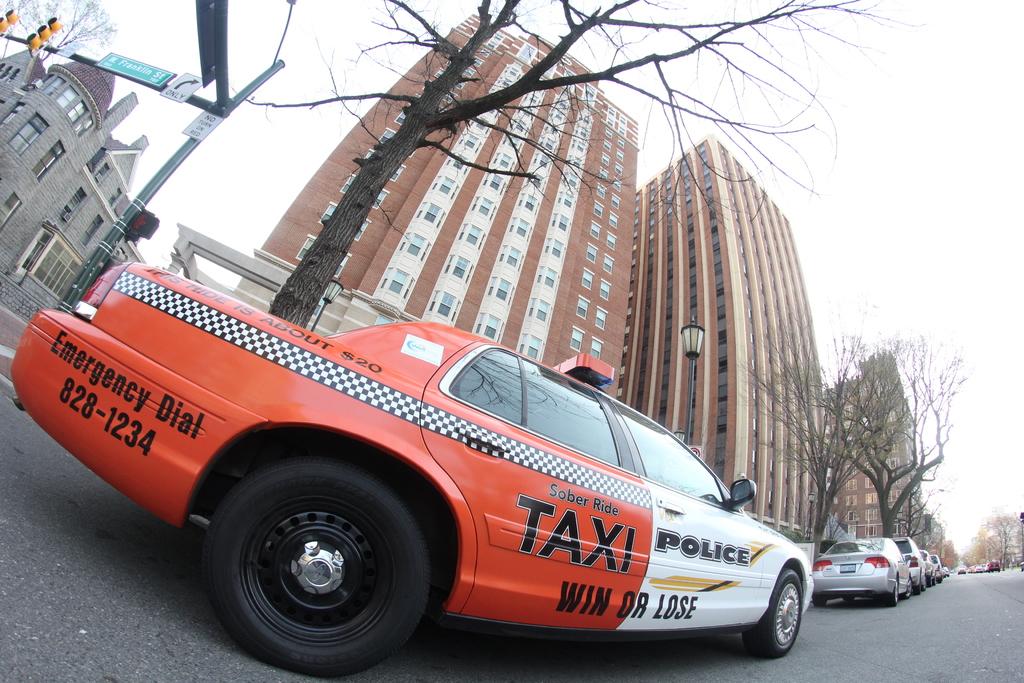What number should you call for an emergency?
Your response must be concise. 828-1234. 